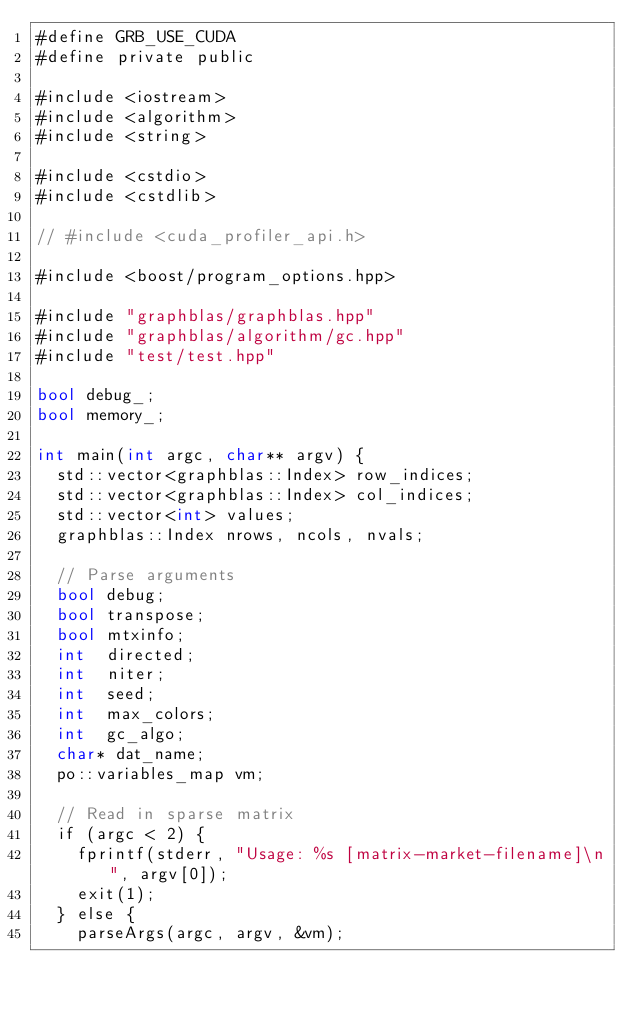<code> <loc_0><loc_0><loc_500><loc_500><_Cuda_>#define GRB_USE_CUDA
#define private public

#include <iostream>
#include <algorithm>
#include <string>

#include <cstdio>
#include <cstdlib>

// #include <cuda_profiler_api.h>

#include <boost/program_options.hpp>

#include "graphblas/graphblas.hpp"
#include "graphblas/algorithm/gc.hpp"
#include "test/test.hpp"

bool debug_;
bool memory_;

int main(int argc, char** argv) {
  std::vector<graphblas::Index> row_indices;
  std::vector<graphblas::Index> col_indices;
  std::vector<int> values;
  graphblas::Index nrows, ncols, nvals;

  // Parse arguments
  bool debug;
  bool transpose;
  bool mtxinfo;
  int  directed;
  int  niter;
  int  seed;
  int  max_colors;
  int  gc_algo;
  char* dat_name;
  po::variables_map vm;

  // Read in sparse matrix
  if (argc < 2) {
    fprintf(stderr, "Usage: %s [matrix-market-filename]\n", argv[0]);
    exit(1);
  } else {
    parseArgs(argc, argv, &vm);</code> 